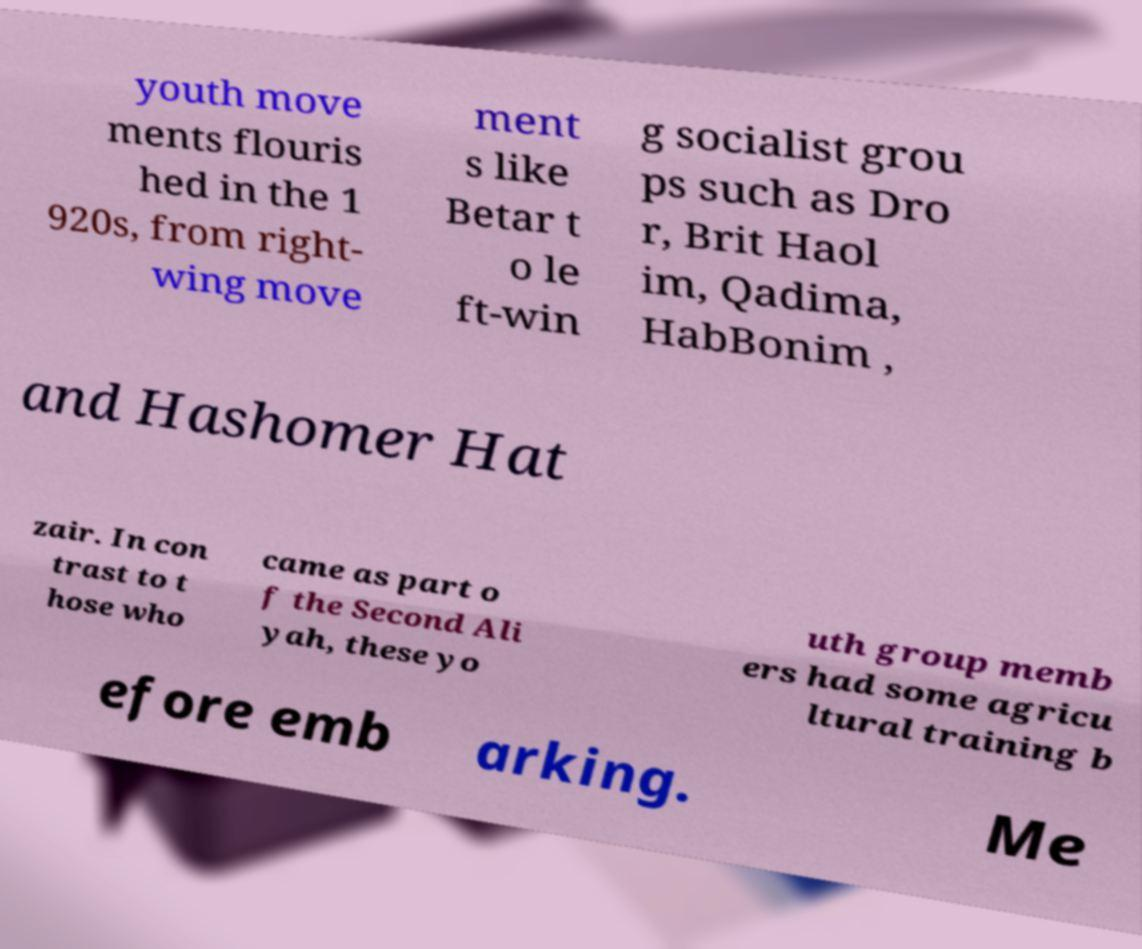Could you extract and type out the text from this image? youth move ments flouris hed in the 1 920s, from right- wing move ment s like Betar t o le ft-win g socialist grou ps such as Dro r, Brit Haol im, Qadima, HabBonim , and Hashomer Hat zair. In con trast to t hose who came as part o f the Second Ali yah, these yo uth group memb ers had some agricu ltural training b efore emb arking. Me 